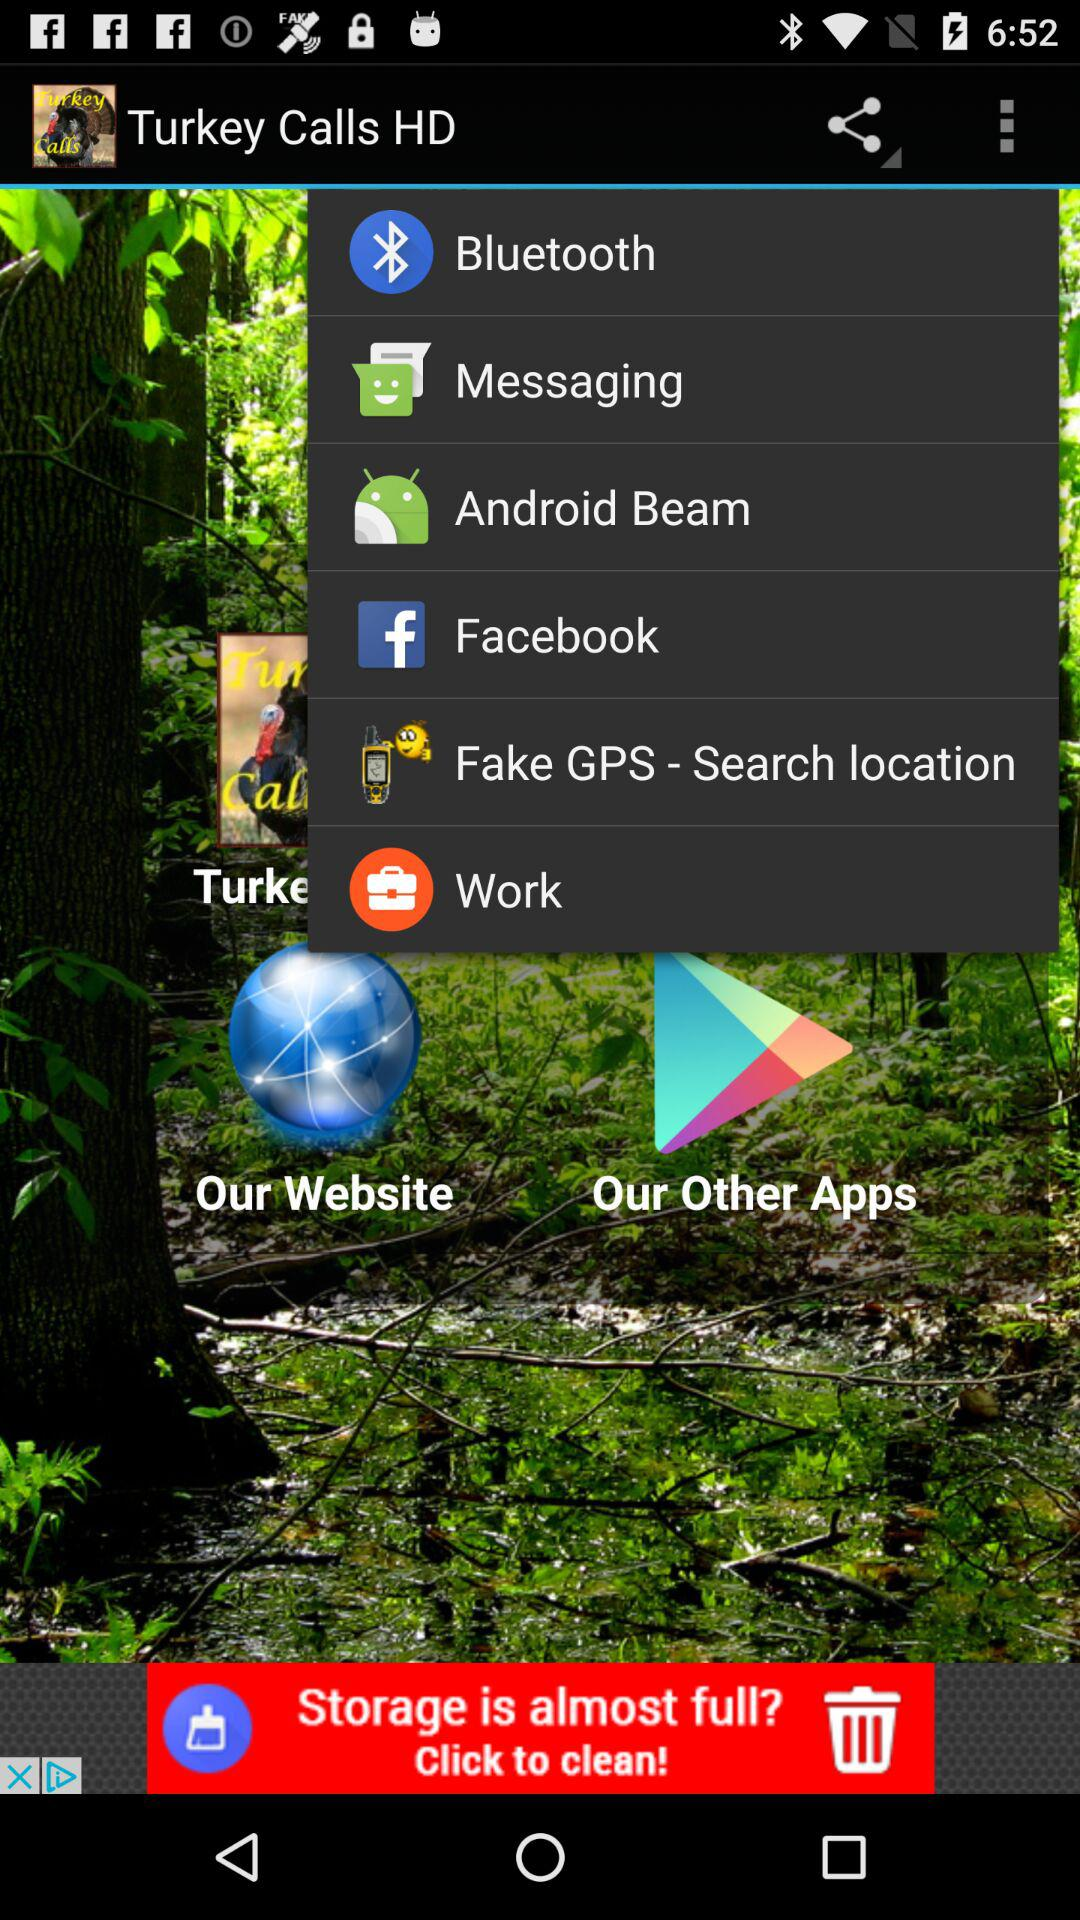What are the sharing options? The sharing options are "Bluetooth", "Messaging", "Android Beam", "Facebook", "Fake GPS - Search location" and "Work". 